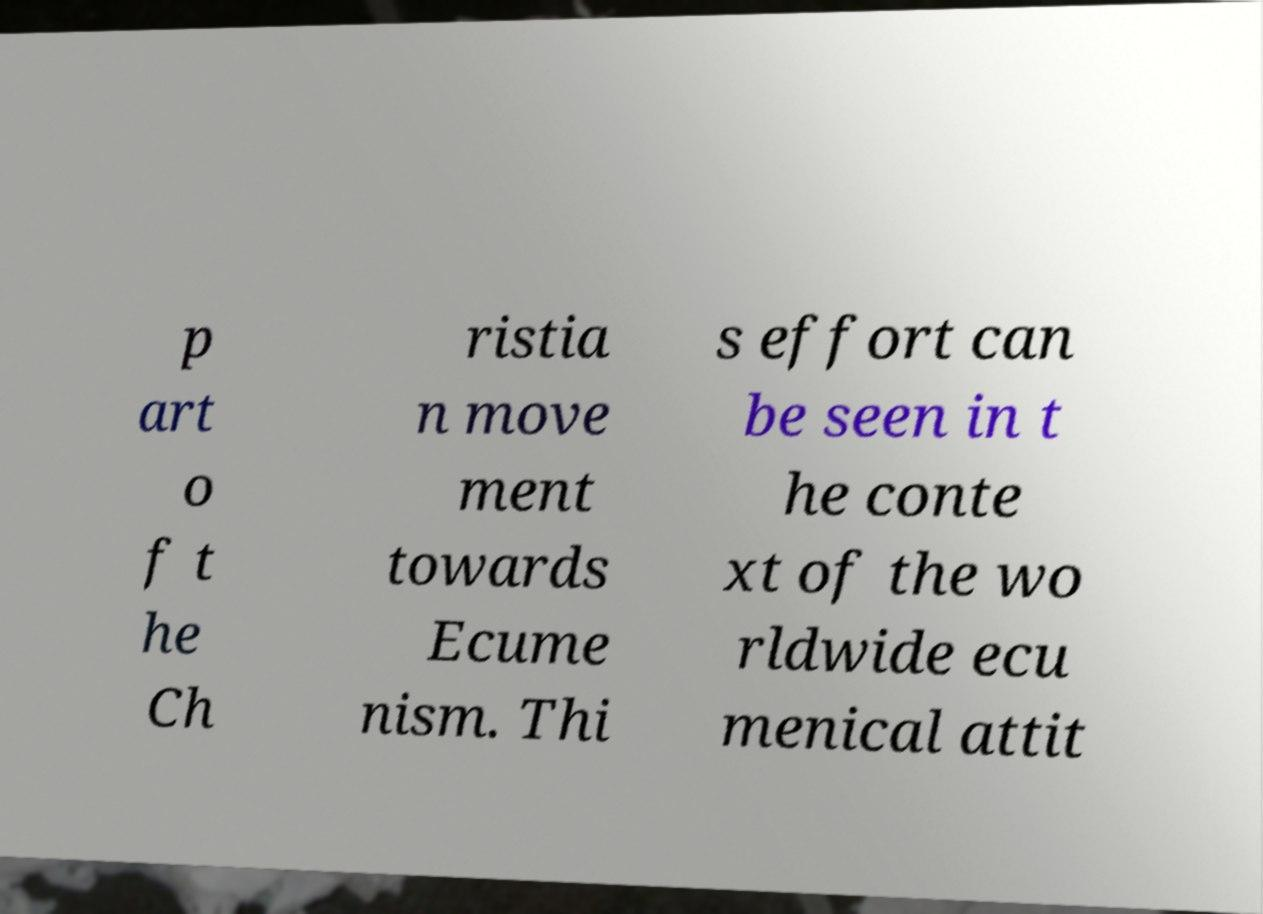Can you accurately transcribe the text from the provided image for me? p art o f t he Ch ristia n move ment towards Ecume nism. Thi s effort can be seen in t he conte xt of the wo rldwide ecu menical attit 